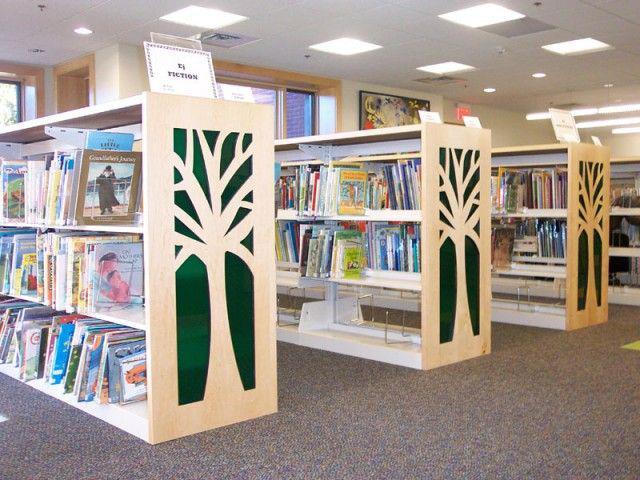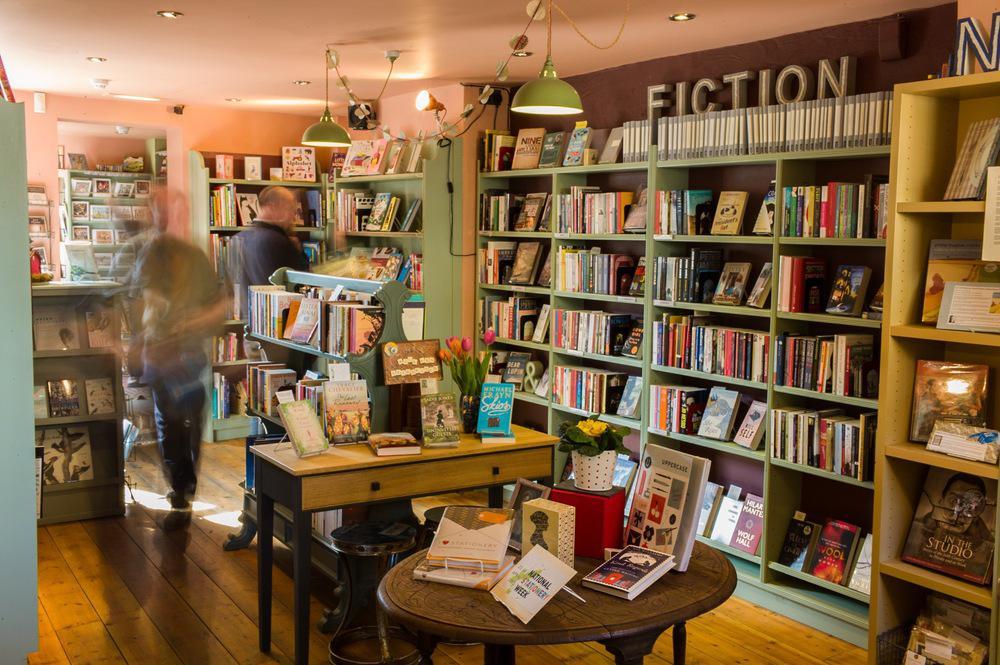The first image is the image on the left, the second image is the image on the right. Evaluate the accuracy of this statement regarding the images: "In one of the images, the people shop are sitting and reading.". Is it true? Answer yes or no. No. The first image is the image on the left, the second image is the image on the right. For the images shown, is this caption "There are at least two people in the bookstore, one adult and one child reading." true? Answer yes or no. No. 